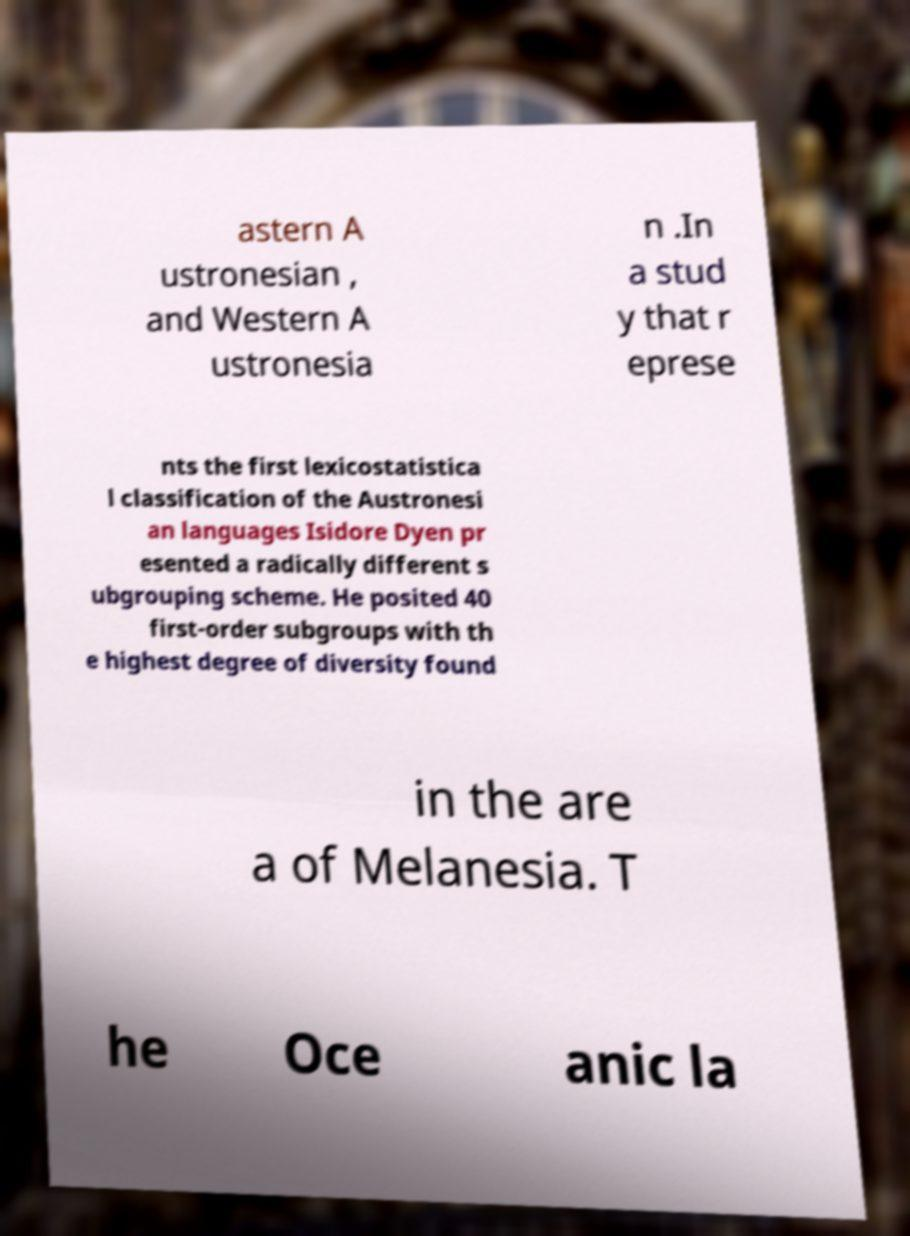Could you assist in decoding the text presented in this image and type it out clearly? astern A ustronesian , and Western A ustronesia n .In a stud y that r eprese nts the first lexicostatistica l classification of the Austronesi an languages Isidore Dyen pr esented a radically different s ubgrouping scheme. He posited 40 first-order subgroups with th e highest degree of diversity found in the are a of Melanesia. T he Oce anic la 